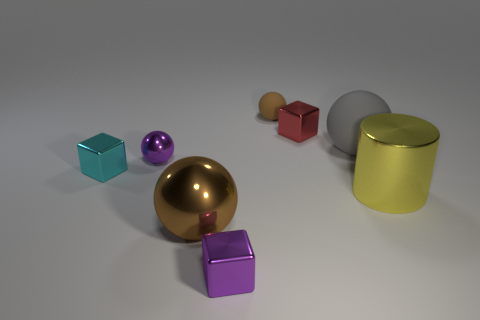How big is the cyan object?
Your answer should be compact. Small. Are there any red balls made of the same material as the cylinder?
Your answer should be very brief. No. What size is the purple object that is the same shape as the tiny cyan object?
Provide a succinct answer. Small. Is the number of brown metallic spheres in front of the cyan metallic cube the same as the number of tiny red metallic blocks?
Ensure brevity in your answer.  Yes. Does the purple shiny thing that is in front of the purple ball have the same shape as the gray matte object?
Offer a very short reply. No. There is a tiny red shiny thing; what shape is it?
Provide a short and direct response. Cube. There is a brown object that is in front of the brown rubber object that is behind the shiny object right of the red metal object; what is its material?
Provide a succinct answer. Metal. There is a large thing that is the same color as the tiny rubber sphere; what is its material?
Provide a succinct answer. Metal. How many objects are either big purple metallic spheres or big brown things?
Provide a succinct answer. 1. Is the brown ball behind the big brown metal thing made of the same material as the tiny red block?
Your answer should be compact. No. 